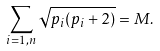Convert formula to latex. <formula><loc_0><loc_0><loc_500><loc_500>\sum _ { i = 1 , n } \sqrt { p _ { i } ( p _ { i } + 2 ) } = M .</formula> 